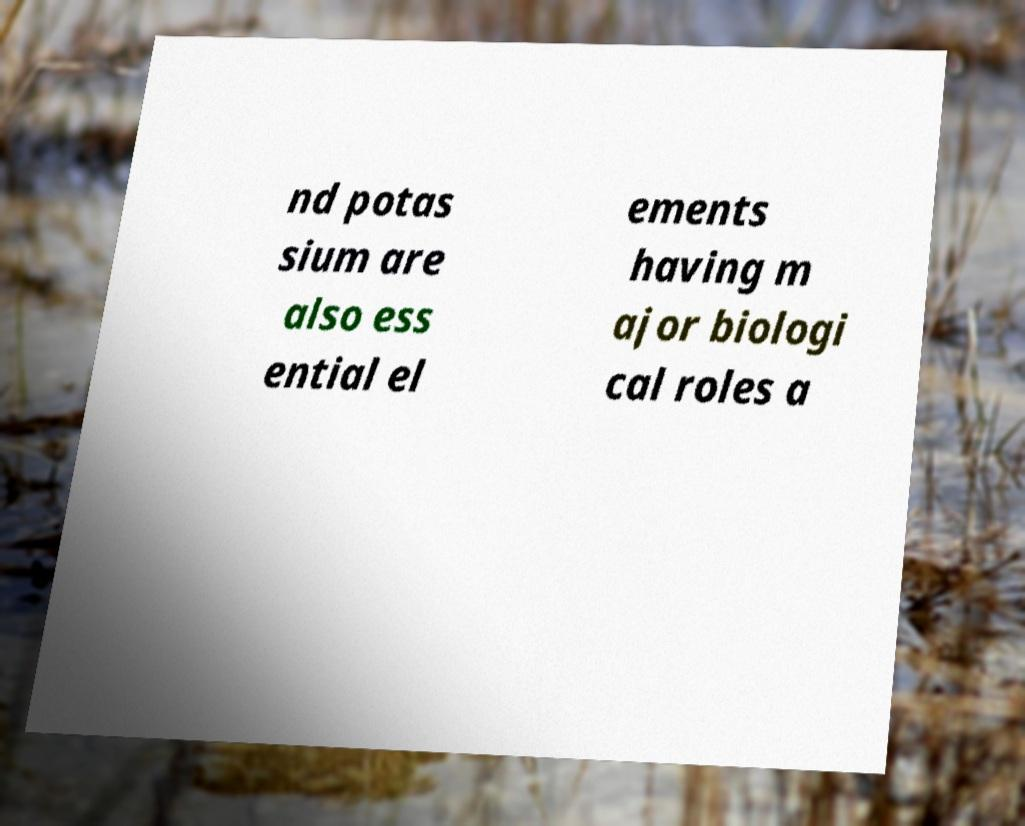For documentation purposes, I need the text within this image transcribed. Could you provide that? nd potas sium are also ess ential el ements having m ajor biologi cal roles a 